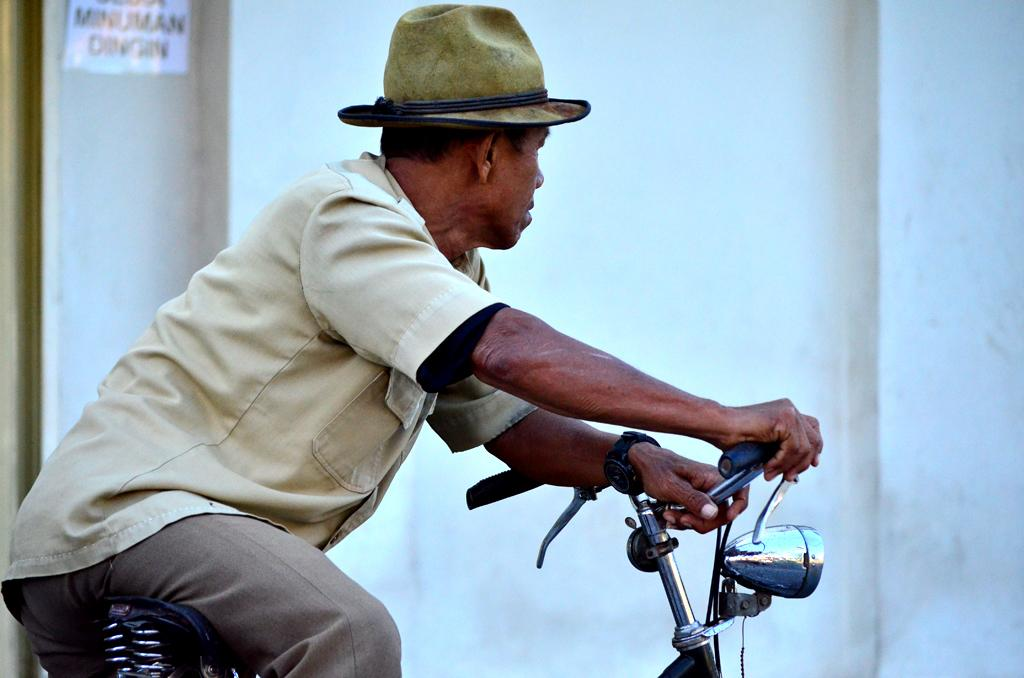Who is the main subject in the image? There is a man in the image. What is the man doing in the image? The man is riding a bicycle. What can be seen in the background of the image? There is a wall in the background of the image. What type of pie is the man holding while riding the bicycle in the image? There is no pie present in the image; the man is riding a bicycle without holding any pie. 